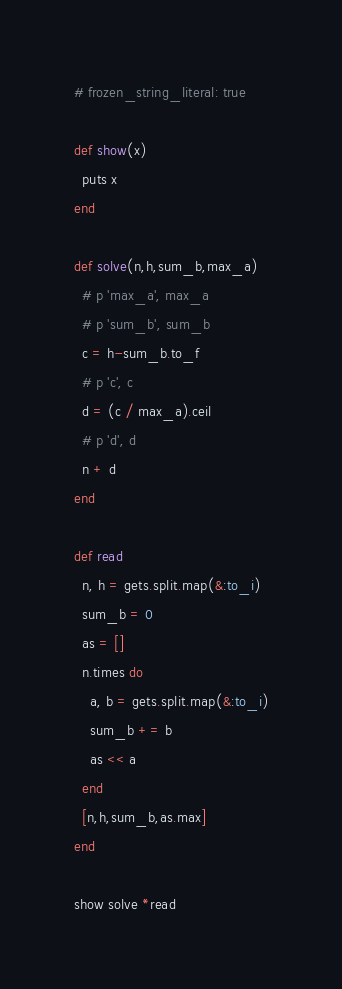Convert code to text. <code><loc_0><loc_0><loc_500><loc_500><_Ruby_># frozen_string_literal: true

def show(x)
  puts x
end

def solve(n,h,sum_b,max_a)
  # p 'max_a', max_a
  # p 'sum_b', sum_b
  c = h-sum_b.to_f
  # p 'c', c
  d = (c / max_a).ceil
  # p 'd', d
  n + d
end

def read
  n, h = gets.split.map(&:to_i)
  sum_b = 0
  as = []
  n.times do
    a, b = gets.split.map(&:to_i)
    sum_b += b
    as << a
  end
  [n,h,sum_b,as.max]
end

show solve *read

</code> 